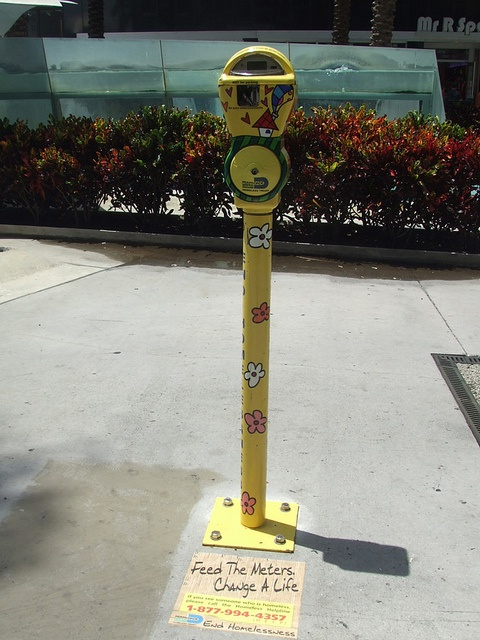Describe the objects in this image and their specific colors. I can see potted plant in ivory, black, maroon, olive, and gray tones, potted plant in ivory, black, gray, darkgreen, and maroon tones, parking meter in ivory, olive, black, maroon, and khaki tones, and potted plant in ivory, black, maroon, olive, and darkgreen tones in this image. 